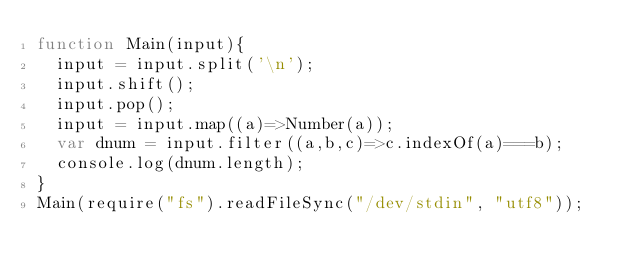Convert code to text. <code><loc_0><loc_0><loc_500><loc_500><_JavaScript_>function Main(input){
  input = input.split('\n');
  input.shift();
  input.pop();
  input = input.map((a)=>Number(a));
  var dnum = input.filter((a,b,c)=>c.indexOf(a)===b);
  console.log(dnum.length);
}
Main(require("fs").readFileSync("/dev/stdin", "utf8"));</code> 